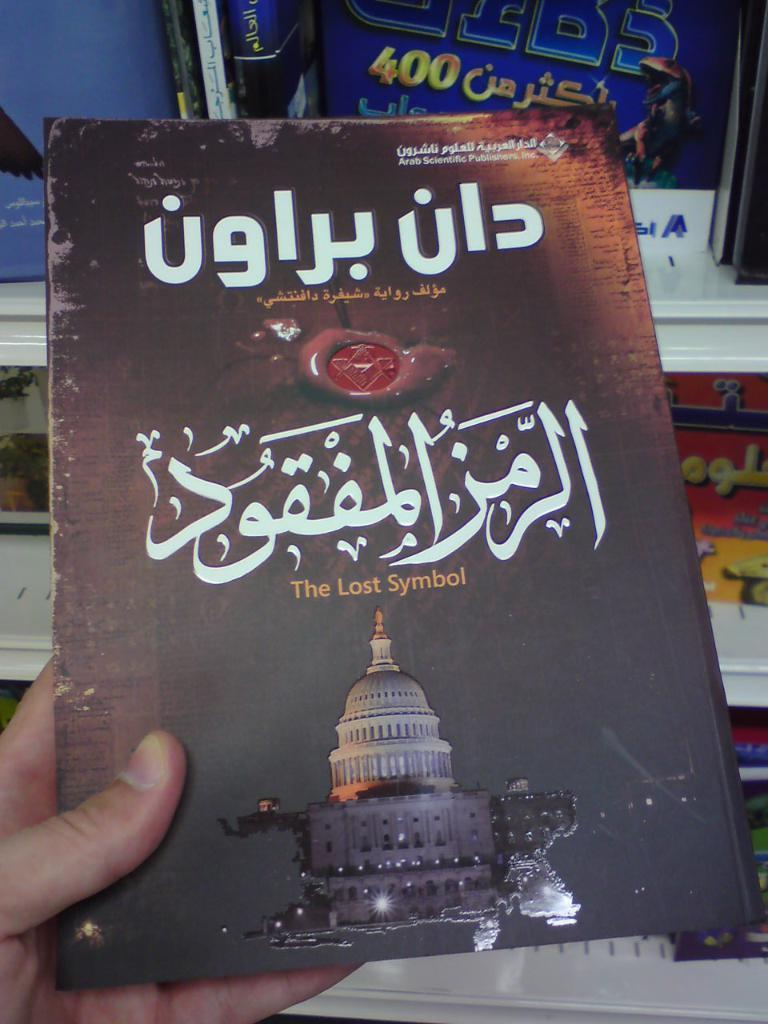<image>
Write a terse but informative summary of the picture. a book that appears to be old and it has arabic language on it 